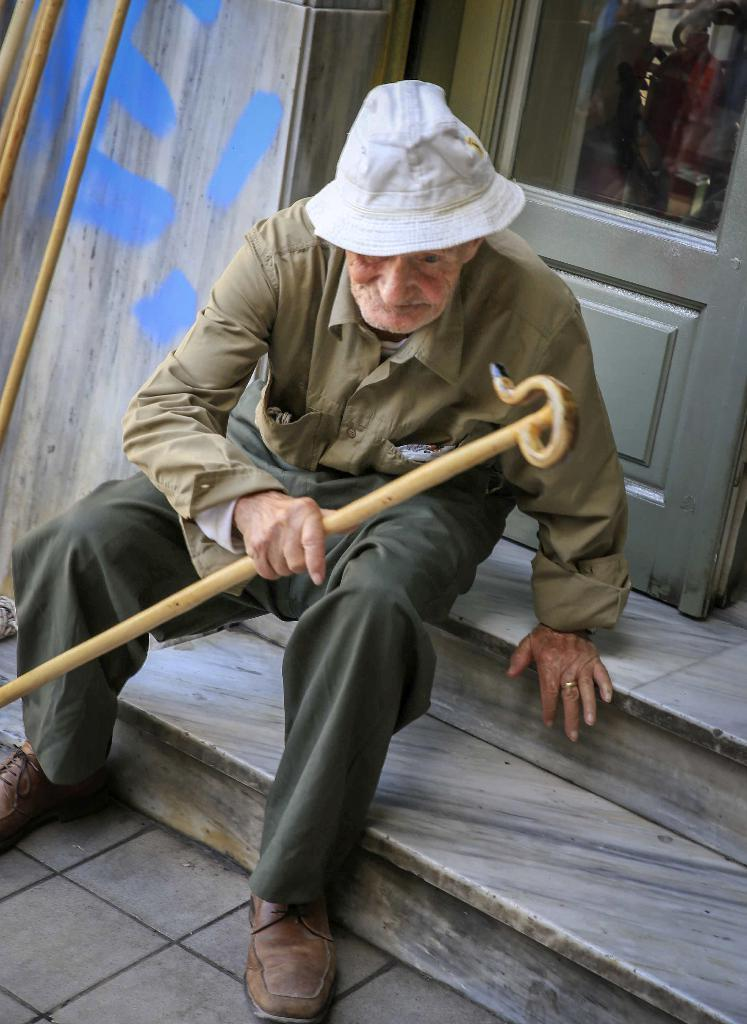What is the main subject of the image? There is a person in the image. Can you describe the person's attire? The person is wearing a hat. What object is the person holding? The person is holding a walking stick. Where is the person located in the image? The person is sitting on the steps. What can be seen in the background of the image? There is a door with a glass panel and a wall in the background, as well as some sticks. What type of bread can be seen in the image? There is no bread present in the image. Can you describe the jellyfish swimming in the background? There are no jellyfish in the image; the background features a door with a glass panel, a wall, and some sticks. 